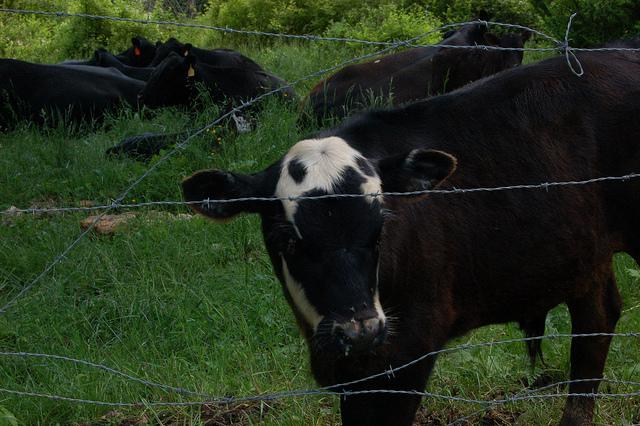Is the term pasteurized relevant to an item obtained from this type of creature?
Answer briefly. Yes. What animal is this?
Concise answer only. Cow. Is the animal going to jump over the fence?
Write a very short answer. No. 